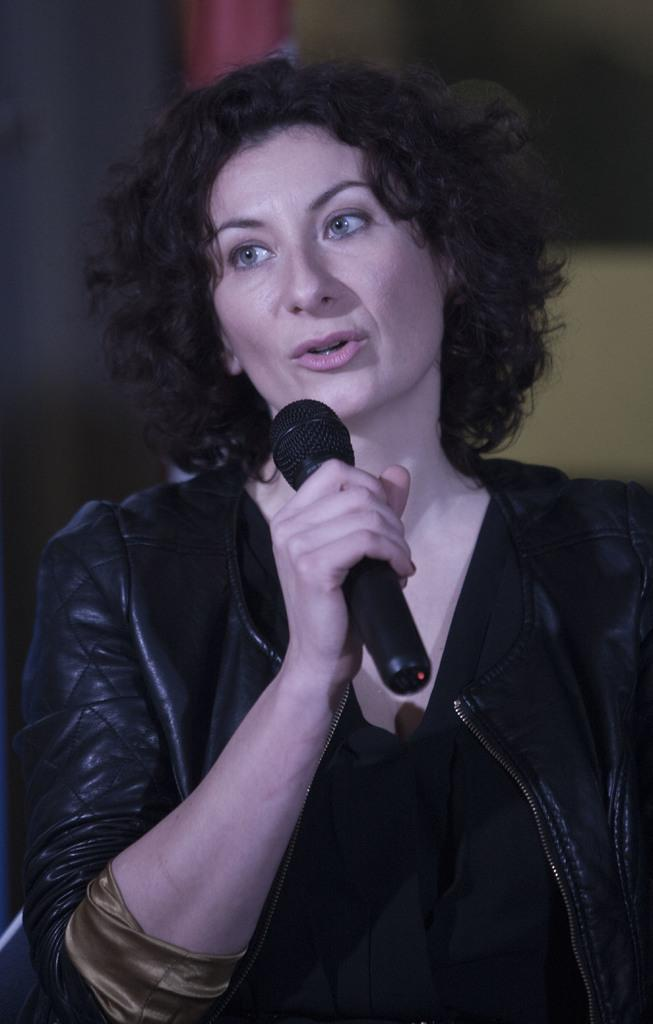What is the main subject of the image? The main subject of the image is a woman. What is the woman holding in the image? The woman is holding a microphone. What is the woman doing with her mouth in the image? The woman's mouth is open. What is the woman wearing in the image? The woman is wearing a black jacket. Is there a swing visible in the image? No, there is no swing present in the image; it features a woman holding a microphone with her mouth open and wearing a black jacket. 